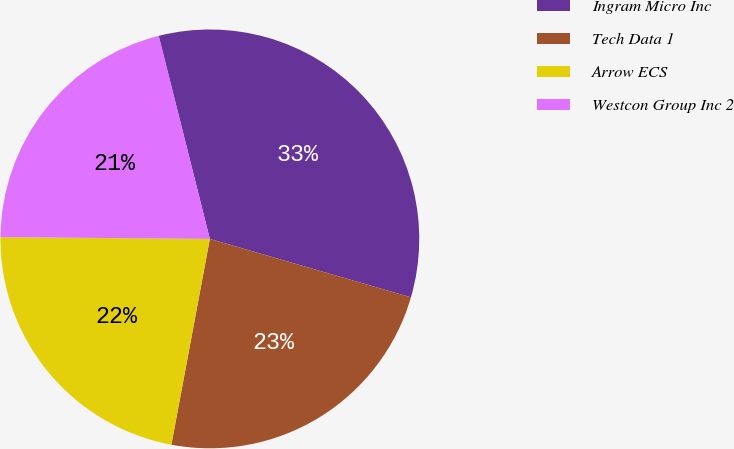Convert chart to OTSL. <chart><loc_0><loc_0><loc_500><loc_500><pie_chart><fcel>Ingram Micro Inc<fcel>Tech Data 1<fcel>Arrow ECS<fcel>Westcon Group Inc 2<nl><fcel>33.43%<fcel>23.44%<fcel>22.19%<fcel>20.94%<nl></chart> 